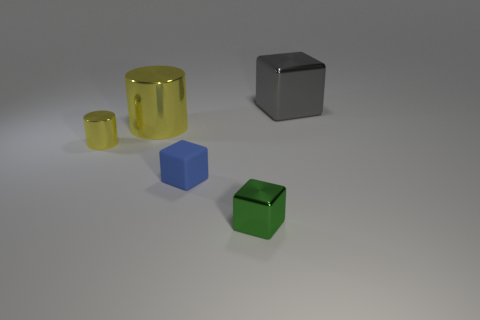How does the size of the green cube compare to the yellow cylinder? The green cube is significantly smaller in size compared to the yellow cylinder, exhibiting a more compact and solid form factor in contrast to the hollow cylindrical shape of the yellow object. 